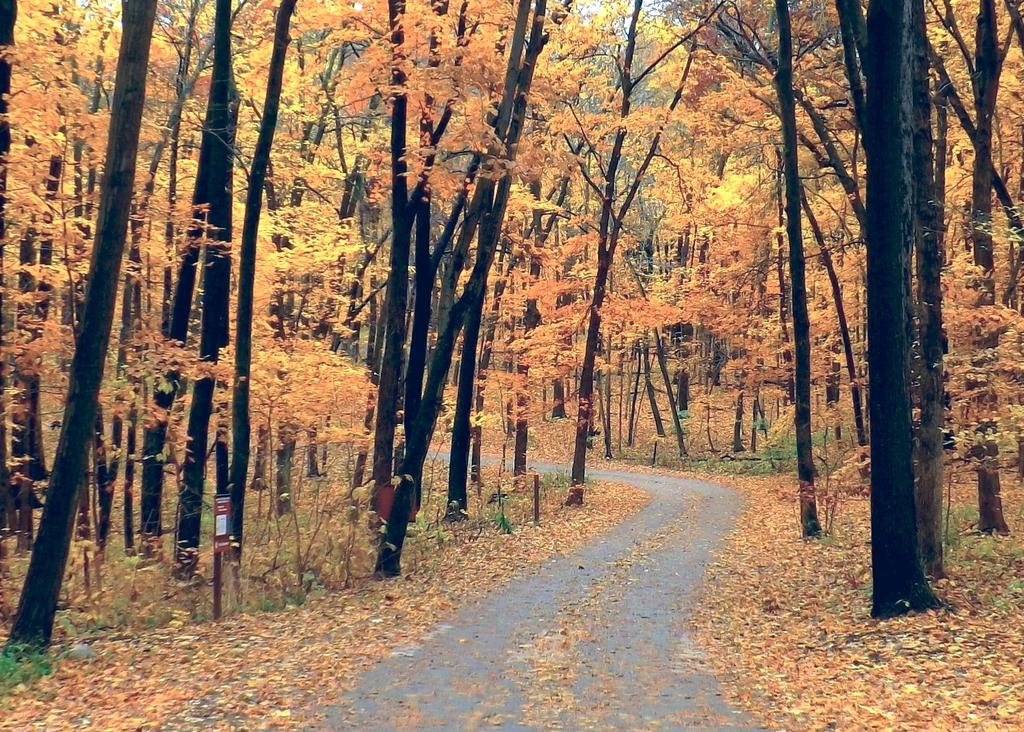What type of natural environment is depicted in the image? The image contains a forest. What can be found in the forest? The forest is full of trees. Is there a specific feature in the forest that stands out? Yes, there is a pathway in the middle of the trees. What type of support can be seen in the image? There is no support visible in the image; it features a forest with trees and a pathway. Is there a cemetery present in the image? No, there is no cemetery in the image; it contains a forest with trees and a pathway. 